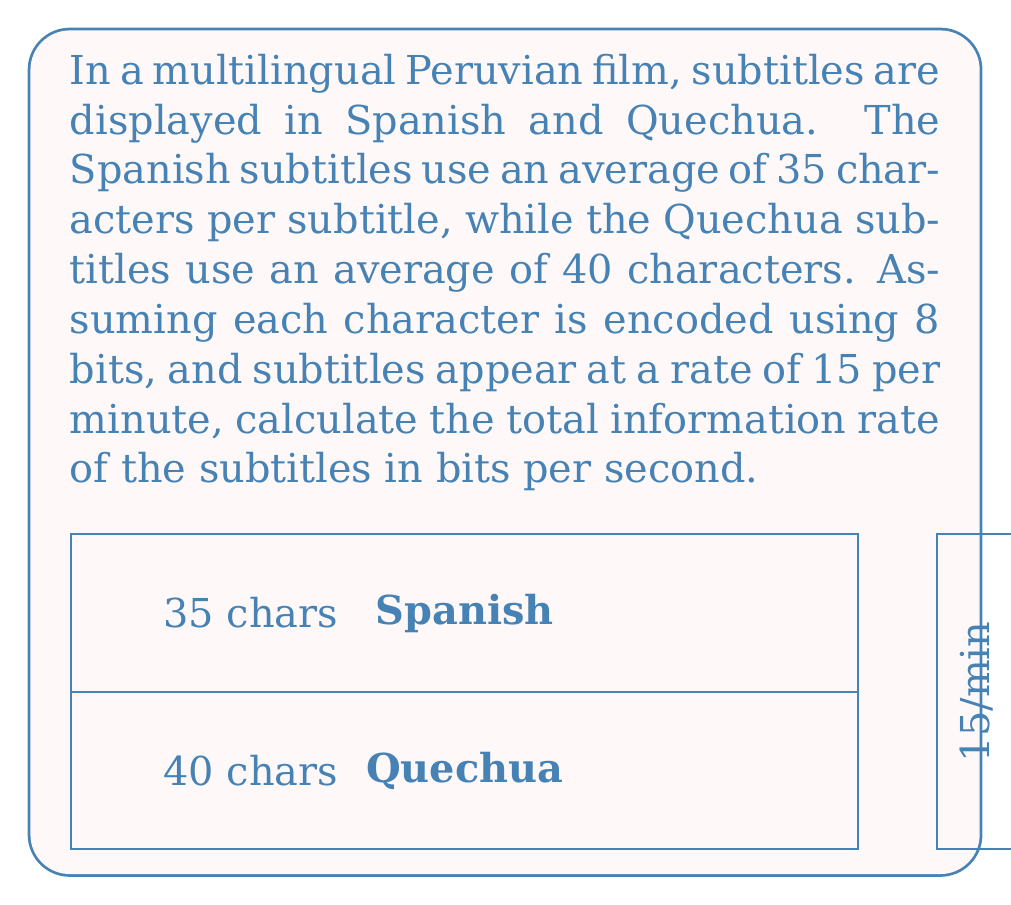Show me your answer to this math problem. Let's approach this step-by-step:

1) First, we need to calculate the number of bits per subtitle for each language:

   Spanish: $35 \text{ characters} \times 8 \text{ bits/character} = 280 \text{ bits}$
   Quechua: $40 \text{ characters} \times 8 \text{ bits/character} = 320 \text{ bits}$

2) Now, we calculate the total bits per subtitle:

   $280 \text{ bits} + 320 \text{ bits} = 600 \text{ bits}$

3) We're given that subtitles appear at a rate of 15 per minute. Let's convert this to subtitles per second:

   $\frac{15 \text{ subtitles}}{60 \text{ seconds}} = 0.25 \text{ subtitles/second}$

4) Now we can calculate the information rate:

   $\text{Information Rate} = 600 \text{ bits/subtitle} \times 0.25 \text{ subtitles/second}$

5) Simplifying:

   $\text{Information Rate} = 150 \text{ bits/second}$

Thus, the total information rate of the subtitles is 150 bits per second.
Answer: 150 bits/second 